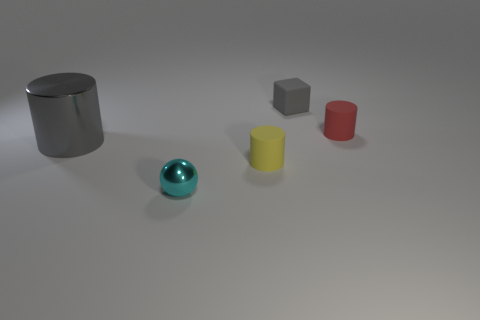Are there any other things that have the same size as the gray cylinder?
Provide a short and direct response. No. Is there anything else that has the same shape as the gray matte object?
Your answer should be compact. No. Is there a big object on the left side of the gray thing that is left of the tiny cyan ball?
Offer a very short reply. No. There is a small yellow rubber object that is on the left side of the small red object; what is its shape?
Keep it short and to the point. Cylinder. There is a cube that is the same color as the large object; what material is it?
Offer a very short reply. Rubber. The object that is in front of the small cylinder that is left of the gray rubber thing is what color?
Make the answer very short. Cyan. Do the red matte cylinder and the gray cube have the same size?
Offer a very short reply. Yes. What material is the red object that is the same shape as the small yellow rubber object?
Your response must be concise. Rubber. What number of gray matte things have the same size as the yellow rubber cylinder?
Your response must be concise. 1. There is a cube that is the same material as the yellow object; what is its color?
Your answer should be very brief. Gray. 